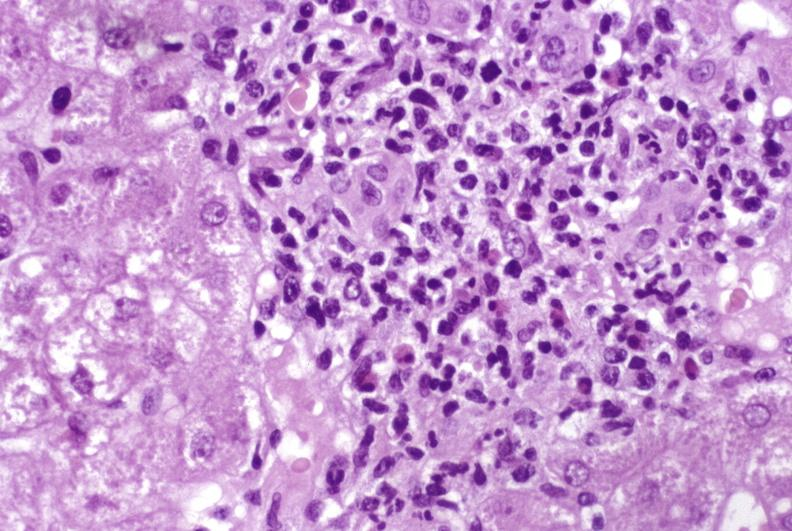s liver present?
Answer the question using a single word or phrase. Yes 